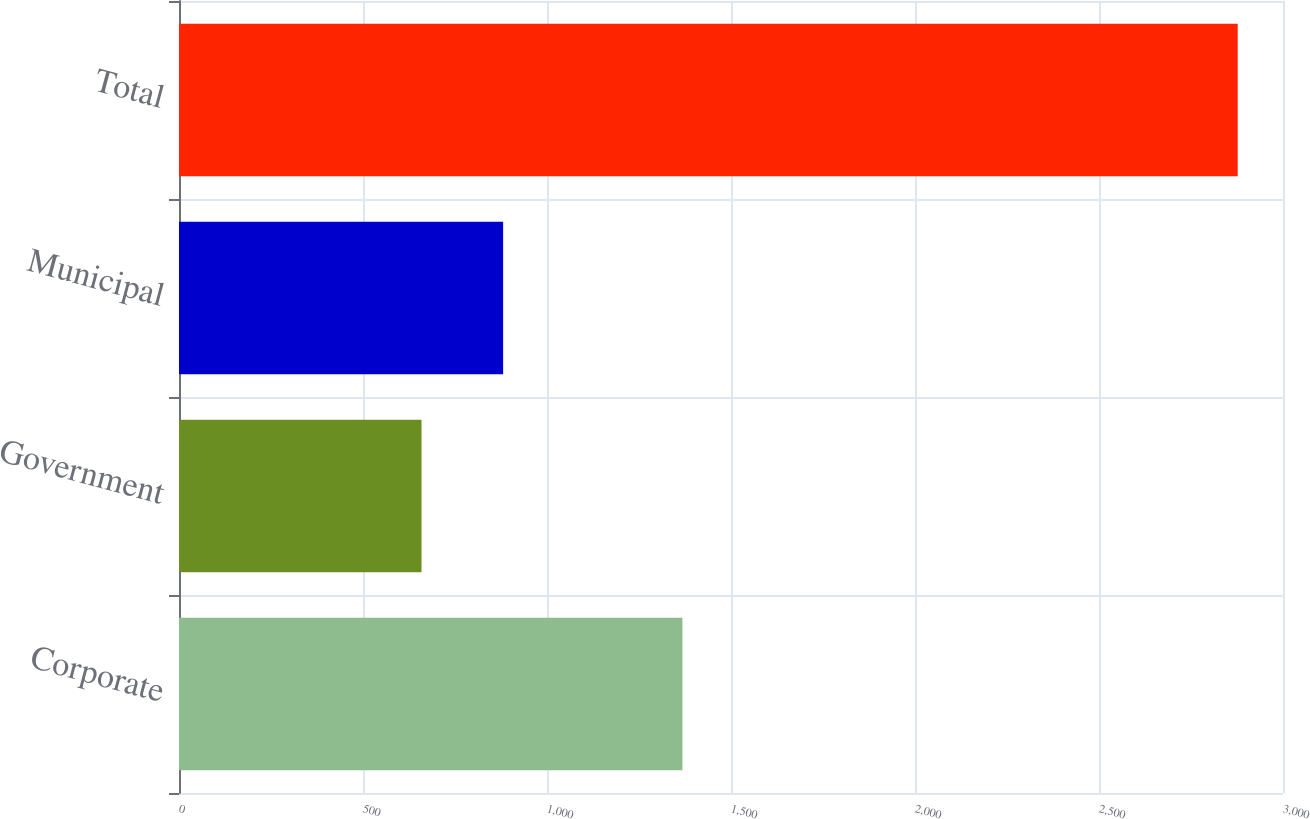<chart> <loc_0><loc_0><loc_500><loc_500><bar_chart><fcel>Corporate<fcel>Government<fcel>Municipal<fcel>Total<nl><fcel>1368<fcel>659<fcel>880.8<fcel>2877<nl></chart> 